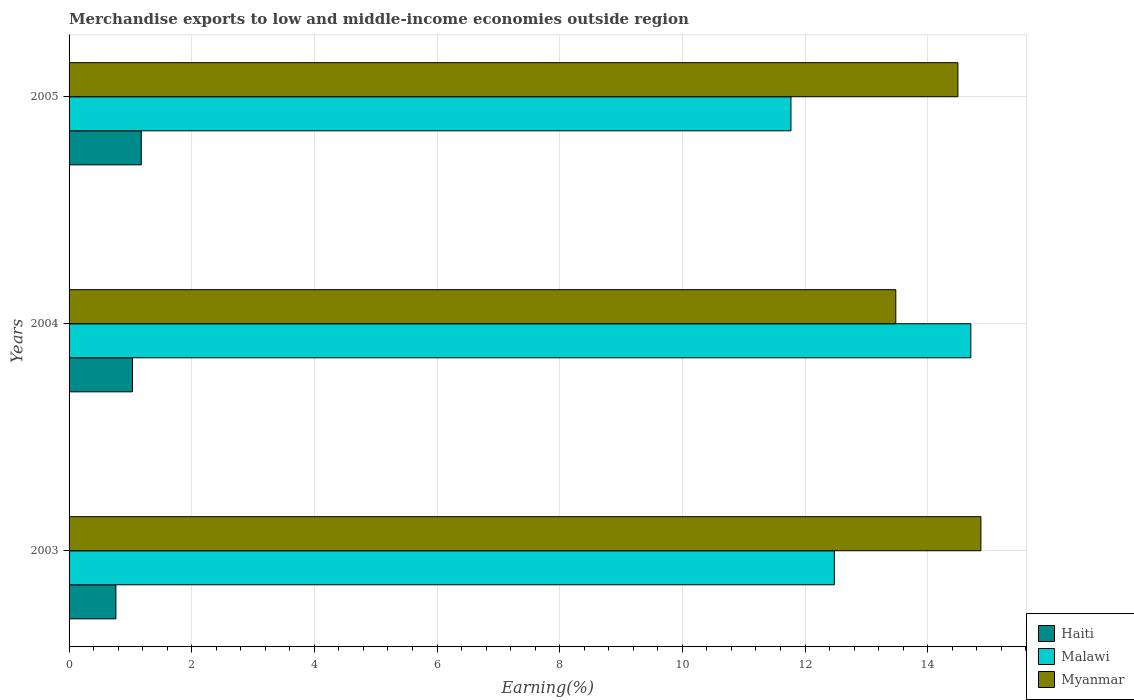How many groups of bars are there?
Your answer should be compact. 3. How many bars are there on the 1st tick from the top?
Your answer should be very brief. 3. How many bars are there on the 2nd tick from the bottom?
Your response must be concise. 3. What is the label of the 1st group of bars from the top?
Offer a terse response. 2005. What is the percentage of amount earned from merchandise exports in Malawi in 2003?
Keep it short and to the point. 12.48. Across all years, what is the maximum percentage of amount earned from merchandise exports in Haiti?
Your answer should be compact. 1.18. Across all years, what is the minimum percentage of amount earned from merchandise exports in Malawi?
Make the answer very short. 11.77. In which year was the percentage of amount earned from merchandise exports in Myanmar minimum?
Ensure brevity in your answer.  2004. What is the total percentage of amount earned from merchandise exports in Myanmar in the graph?
Your answer should be compact. 42.84. What is the difference between the percentage of amount earned from merchandise exports in Haiti in 2003 and that in 2004?
Your answer should be compact. -0.27. What is the difference between the percentage of amount earned from merchandise exports in Myanmar in 2005 and the percentage of amount earned from merchandise exports in Malawi in 2003?
Your answer should be very brief. 2.01. What is the average percentage of amount earned from merchandise exports in Haiti per year?
Make the answer very short. 0.99. In the year 2003, what is the difference between the percentage of amount earned from merchandise exports in Myanmar and percentage of amount earned from merchandise exports in Haiti?
Make the answer very short. 14.1. What is the ratio of the percentage of amount earned from merchandise exports in Haiti in 2003 to that in 2005?
Offer a terse response. 0.65. Is the percentage of amount earned from merchandise exports in Myanmar in 2004 less than that in 2005?
Keep it short and to the point. Yes. Is the difference between the percentage of amount earned from merchandise exports in Myanmar in 2004 and 2005 greater than the difference between the percentage of amount earned from merchandise exports in Haiti in 2004 and 2005?
Give a very brief answer. No. What is the difference between the highest and the second highest percentage of amount earned from merchandise exports in Haiti?
Offer a very short reply. 0.14. What is the difference between the highest and the lowest percentage of amount earned from merchandise exports in Haiti?
Provide a succinct answer. 0.41. What does the 3rd bar from the top in 2004 represents?
Ensure brevity in your answer.  Haiti. What does the 3rd bar from the bottom in 2005 represents?
Ensure brevity in your answer.  Myanmar. Is it the case that in every year, the sum of the percentage of amount earned from merchandise exports in Myanmar and percentage of amount earned from merchandise exports in Malawi is greater than the percentage of amount earned from merchandise exports in Haiti?
Make the answer very short. Yes. How many bars are there?
Give a very brief answer. 9. Are all the bars in the graph horizontal?
Offer a very short reply. Yes. What is the difference between two consecutive major ticks on the X-axis?
Your answer should be compact. 2. Are the values on the major ticks of X-axis written in scientific E-notation?
Ensure brevity in your answer.  No. How many legend labels are there?
Your answer should be compact. 3. How are the legend labels stacked?
Give a very brief answer. Vertical. What is the title of the graph?
Provide a short and direct response. Merchandise exports to low and middle-income economies outside region. What is the label or title of the X-axis?
Keep it short and to the point. Earning(%). What is the Earning(%) in Haiti in 2003?
Give a very brief answer. 0.76. What is the Earning(%) in Malawi in 2003?
Your answer should be compact. 12.48. What is the Earning(%) of Myanmar in 2003?
Your response must be concise. 14.87. What is the Earning(%) in Haiti in 2004?
Keep it short and to the point. 1.03. What is the Earning(%) of Malawi in 2004?
Keep it short and to the point. 14.7. What is the Earning(%) of Myanmar in 2004?
Make the answer very short. 13.48. What is the Earning(%) of Haiti in 2005?
Provide a short and direct response. 1.18. What is the Earning(%) in Malawi in 2005?
Offer a very short reply. 11.77. What is the Earning(%) of Myanmar in 2005?
Make the answer very short. 14.49. Across all years, what is the maximum Earning(%) in Haiti?
Offer a terse response. 1.18. Across all years, what is the maximum Earning(%) of Malawi?
Provide a succinct answer. 14.7. Across all years, what is the maximum Earning(%) in Myanmar?
Provide a succinct answer. 14.87. Across all years, what is the minimum Earning(%) of Haiti?
Your answer should be compact. 0.76. Across all years, what is the minimum Earning(%) of Malawi?
Your response must be concise. 11.77. Across all years, what is the minimum Earning(%) in Myanmar?
Your answer should be compact. 13.48. What is the total Earning(%) in Haiti in the graph?
Your answer should be compact. 2.98. What is the total Earning(%) in Malawi in the graph?
Keep it short and to the point. 38.95. What is the total Earning(%) of Myanmar in the graph?
Offer a terse response. 42.84. What is the difference between the Earning(%) of Haiti in 2003 and that in 2004?
Offer a very short reply. -0.27. What is the difference between the Earning(%) in Malawi in 2003 and that in 2004?
Give a very brief answer. -2.23. What is the difference between the Earning(%) of Myanmar in 2003 and that in 2004?
Make the answer very short. 1.39. What is the difference between the Earning(%) in Haiti in 2003 and that in 2005?
Your response must be concise. -0.41. What is the difference between the Earning(%) of Malawi in 2003 and that in 2005?
Offer a very short reply. 0.71. What is the difference between the Earning(%) of Myanmar in 2003 and that in 2005?
Offer a terse response. 0.37. What is the difference between the Earning(%) in Haiti in 2004 and that in 2005?
Provide a succinct answer. -0.14. What is the difference between the Earning(%) of Malawi in 2004 and that in 2005?
Your response must be concise. 2.93. What is the difference between the Earning(%) in Myanmar in 2004 and that in 2005?
Your answer should be very brief. -1.01. What is the difference between the Earning(%) of Haiti in 2003 and the Earning(%) of Malawi in 2004?
Your answer should be very brief. -13.94. What is the difference between the Earning(%) in Haiti in 2003 and the Earning(%) in Myanmar in 2004?
Keep it short and to the point. -12.72. What is the difference between the Earning(%) in Malawi in 2003 and the Earning(%) in Myanmar in 2004?
Ensure brevity in your answer.  -1. What is the difference between the Earning(%) in Haiti in 2003 and the Earning(%) in Malawi in 2005?
Your answer should be very brief. -11.01. What is the difference between the Earning(%) of Haiti in 2003 and the Earning(%) of Myanmar in 2005?
Your response must be concise. -13.73. What is the difference between the Earning(%) in Malawi in 2003 and the Earning(%) in Myanmar in 2005?
Your response must be concise. -2.01. What is the difference between the Earning(%) of Haiti in 2004 and the Earning(%) of Malawi in 2005?
Your answer should be very brief. -10.74. What is the difference between the Earning(%) in Haiti in 2004 and the Earning(%) in Myanmar in 2005?
Ensure brevity in your answer.  -13.46. What is the difference between the Earning(%) of Malawi in 2004 and the Earning(%) of Myanmar in 2005?
Your response must be concise. 0.21. What is the average Earning(%) in Haiti per year?
Offer a terse response. 0.99. What is the average Earning(%) in Malawi per year?
Your response must be concise. 12.98. What is the average Earning(%) in Myanmar per year?
Provide a short and direct response. 14.28. In the year 2003, what is the difference between the Earning(%) of Haiti and Earning(%) of Malawi?
Your answer should be compact. -11.72. In the year 2003, what is the difference between the Earning(%) in Haiti and Earning(%) in Myanmar?
Provide a succinct answer. -14.1. In the year 2003, what is the difference between the Earning(%) of Malawi and Earning(%) of Myanmar?
Keep it short and to the point. -2.39. In the year 2004, what is the difference between the Earning(%) of Haiti and Earning(%) of Malawi?
Ensure brevity in your answer.  -13.67. In the year 2004, what is the difference between the Earning(%) in Haiti and Earning(%) in Myanmar?
Offer a terse response. -12.45. In the year 2004, what is the difference between the Earning(%) of Malawi and Earning(%) of Myanmar?
Ensure brevity in your answer.  1.22. In the year 2005, what is the difference between the Earning(%) in Haiti and Earning(%) in Malawi?
Your answer should be very brief. -10.59. In the year 2005, what is the difference between the Earning(%) in Haiti and Earning(%) in Myanmar?
Provide a short and direct response. -13.32. In the year 2005, what is the difference between the Earning(%) in Malawi and Earning(%) in Myanmar?
Your answer should be very brief. -2.72. What is the ratio of the Earning(%) of Haiti in 2003 to that in 2004?
Ensure brevity in your answer.  0.74. What is the ratio of the Earning(%) in Malawi in 2003 to that in 2004?
Your answer should be compact. 0.85. What is the ratio of the Earning(%) of Myanmar in 2003 to that in 2004?
Your answer should be compact. 1.1. What is the ratio of the Earning(%) in Haiti in 2003 to that in 2005?
Ensure brevity in your answer.  0.65. What is the ratio of the Earning(%) in Malawi in 2003 to that in 2005?
Provide a short and direct response. 1.06. What is the ratio of the Earning(%) in Myanmar in 2003 to that in 2005?
Your answer should be very brief. 1.03. What is the ratio of the Earning(%) of Haiti in 2004 to that in 2005?
Your answer should be compact. 0.88. What is the ratio of the Earning(%) of Malawi in 2004 to that in 2005?
Give a very brief answer. 1.25. What is the ratio of the Earning(%) in Myanmar in 2004 to that in 2005?
Offer a very short reply. 0.93. What is the difference between the highest and the second highest Earning(%) in Haiti?
Provide a short and direct response. 0.14. What is the difference between the highest and the second highest Earning(%) of Malawi?
Make the answer very short. 2.23. What is the difference between the highest and the second highest Earning(%) in Myanmar?
Your response must be concise. 0.37. What is the difference between the highest and the lowest Earning(%) in Haiti?
Your response must be concise. 0.41. What is the difference between the highest and the lowest Earning(%) of Malawi?
Your answer should be very brief. 2.93. What is the difference between the highest and the lowest Earning(%) of Myanmar?
Provide a short and direct response. 1.39. 